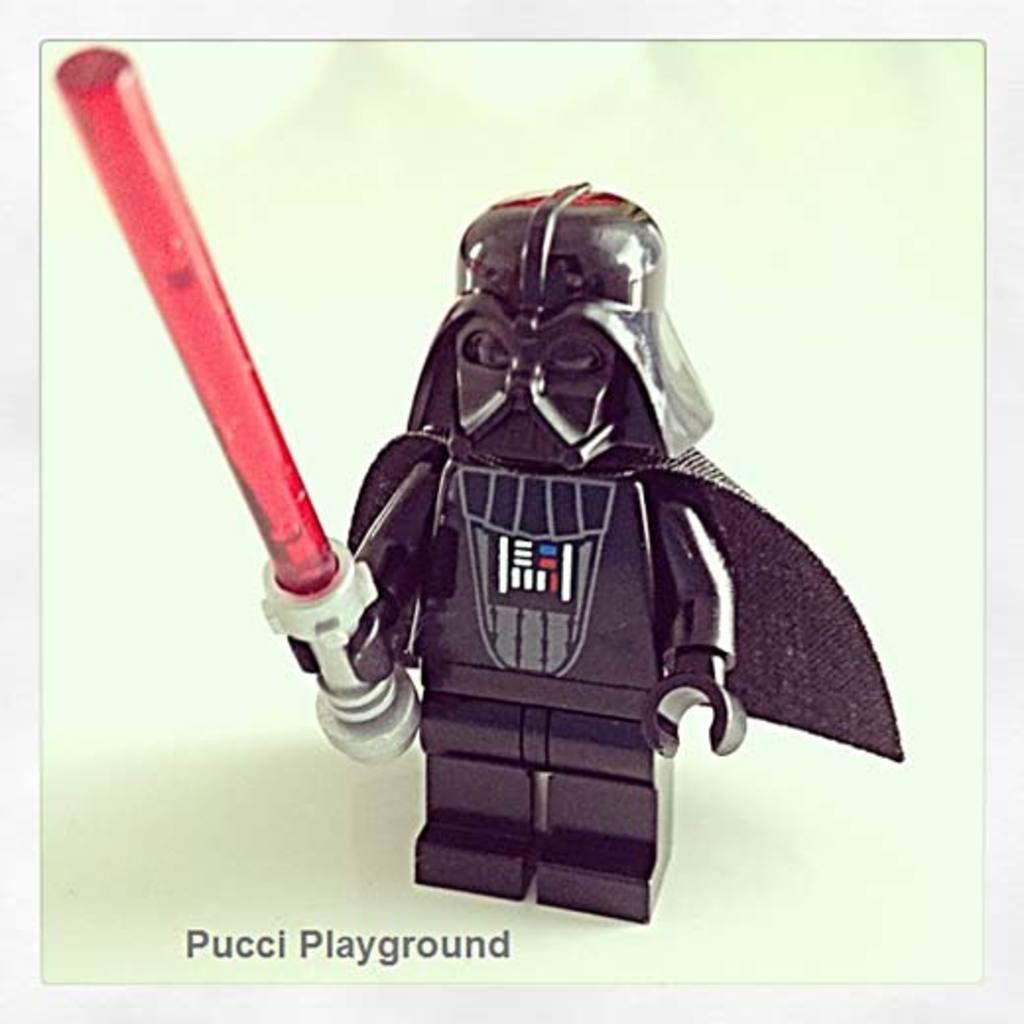Can you describe this image briefly? In this image we can see a toy. The background is white in color. We can see some text at the bottom of the image. 